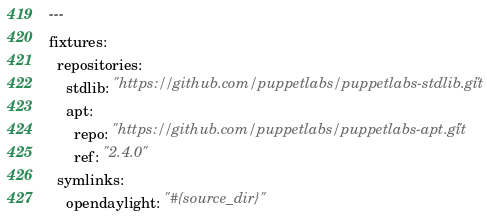<code> <loc_0><loc_0><loc_500><loc_500><_YAML_>---
fixtures:
  repositories:
    stdlib: "https://github.com/puppetlabs/puppetlabs-stdlib.git"
    apt:
      repo: "https://github.com/puppetlabs/puppetlabs-apt.git"
      ref: "2.4.0"
  symlinks:
    opendaylight: "#{source_dir}"
</code> 